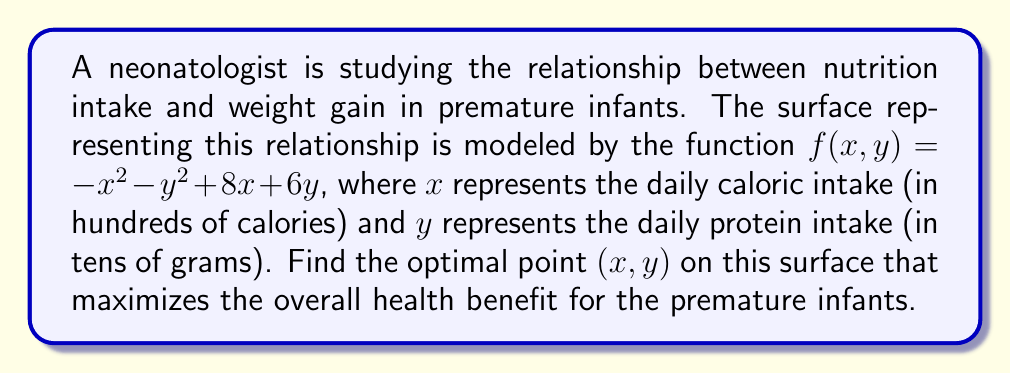Teach me how to tackle this problem. To find the optimal point on the surface, we need to locate the maximum of the function $f(x,y) = -x^2 - y^2 + 8x + 6y$. This can be done by following these steps:

1) First, we calculate the partial derivatives of $f$ with respect to $x$ and $y$:

   $\frac{\partial f}{\partial x} = -2x + 8$
   $\frac{\partial f}{\partial y} = -2y + 6$

2) At the maximum point, both partial derivatives should equal zero. So we set up the system of equations:

   $-2x + 8 = 0$
   $-2y + 6 = 0$

3) Solving these equations:

   From the first equation: $-2x + 8 = 0$
                            $-2x = -8$
                            $x = 4$

   From the second equation: $-2y + 6 = 0$
                             $-2y = -6$
                             $y = 3$

4) Therefore, the critical point is (4, 3).

5) To confirm this is a maximum, we can check the second partial derivatives:

   $\frac{\partial^2 f}{\partial x^2} = -2$
   $\frac{\partial^2 f}{\partial y^2} = -2$
   $\frac{\partial^2 f}{\partial x\partial y} = 0$

   The Hessian matrix at (4, 3) is:
   $$H = \begin{bmatrix} -2 & 0 \\ 0 & -2 \end{bmatrix}$$

   Since both eigenvalues of this matrix are negative, the point (4, 3) is indeed a local maximum.

6) Interpreting the result: The optimal point occurs at $x = 4$ and $y = 3$, which corresponds to a daily caloric intake of 400 calories and a daily protein intake of 30 grams.
Answer: (4, 3) 